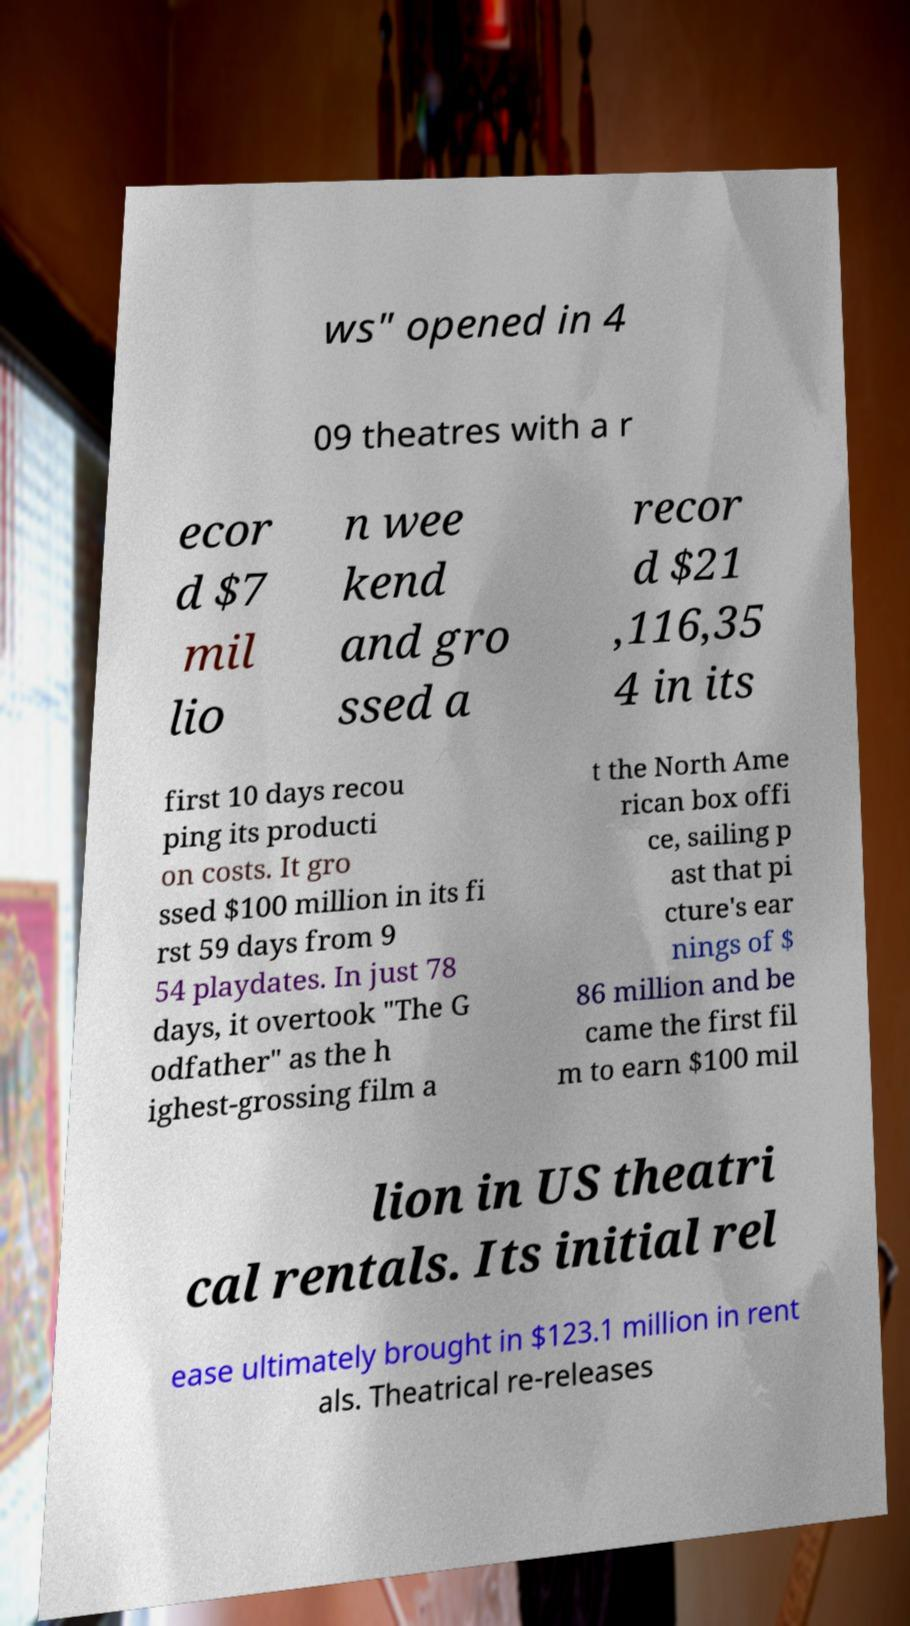Please identify and transcribe the text found in this image. ws" opened in 4 09 theatres with a r ecor d $7 mil lio n wee kend and gro ssed a recor d $21 ,116,35 4 in its first 10 days recou ping its producti on costs. It gro ssed $100 million in its fi rst 59 days from 9 54 playdates. In just 78 days, it overtook "The G odfather" as the h ighest-grossing film a t the North Ame rican box offi ce, sailing p ast that pi cture's ear nings of $ 86 million and be came the first fil m to earn $100 mil lion in US theatri cal rentals. Its initial rel ease ultimately brought in $123.1 million in rent als. Theatrical re-releases 